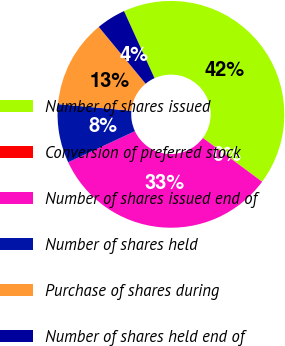Convert chart to OTSL. <chart><loc_0><loc_0><loc_500><loc_500><pie_chart><fcel>Number of shares issued<fcel>Conversion of preferred stock<fcel>Number of shares issued end of<fcel>Number of shares held<fcel>Purchase of shares during<fcel>Number of shares held end of<nl><fcel>41.92%<fcel>0.0%<fcel>32.92%<fcel>8.39%<fcel>12.58%<fcel>4.19%<nl></chart> 